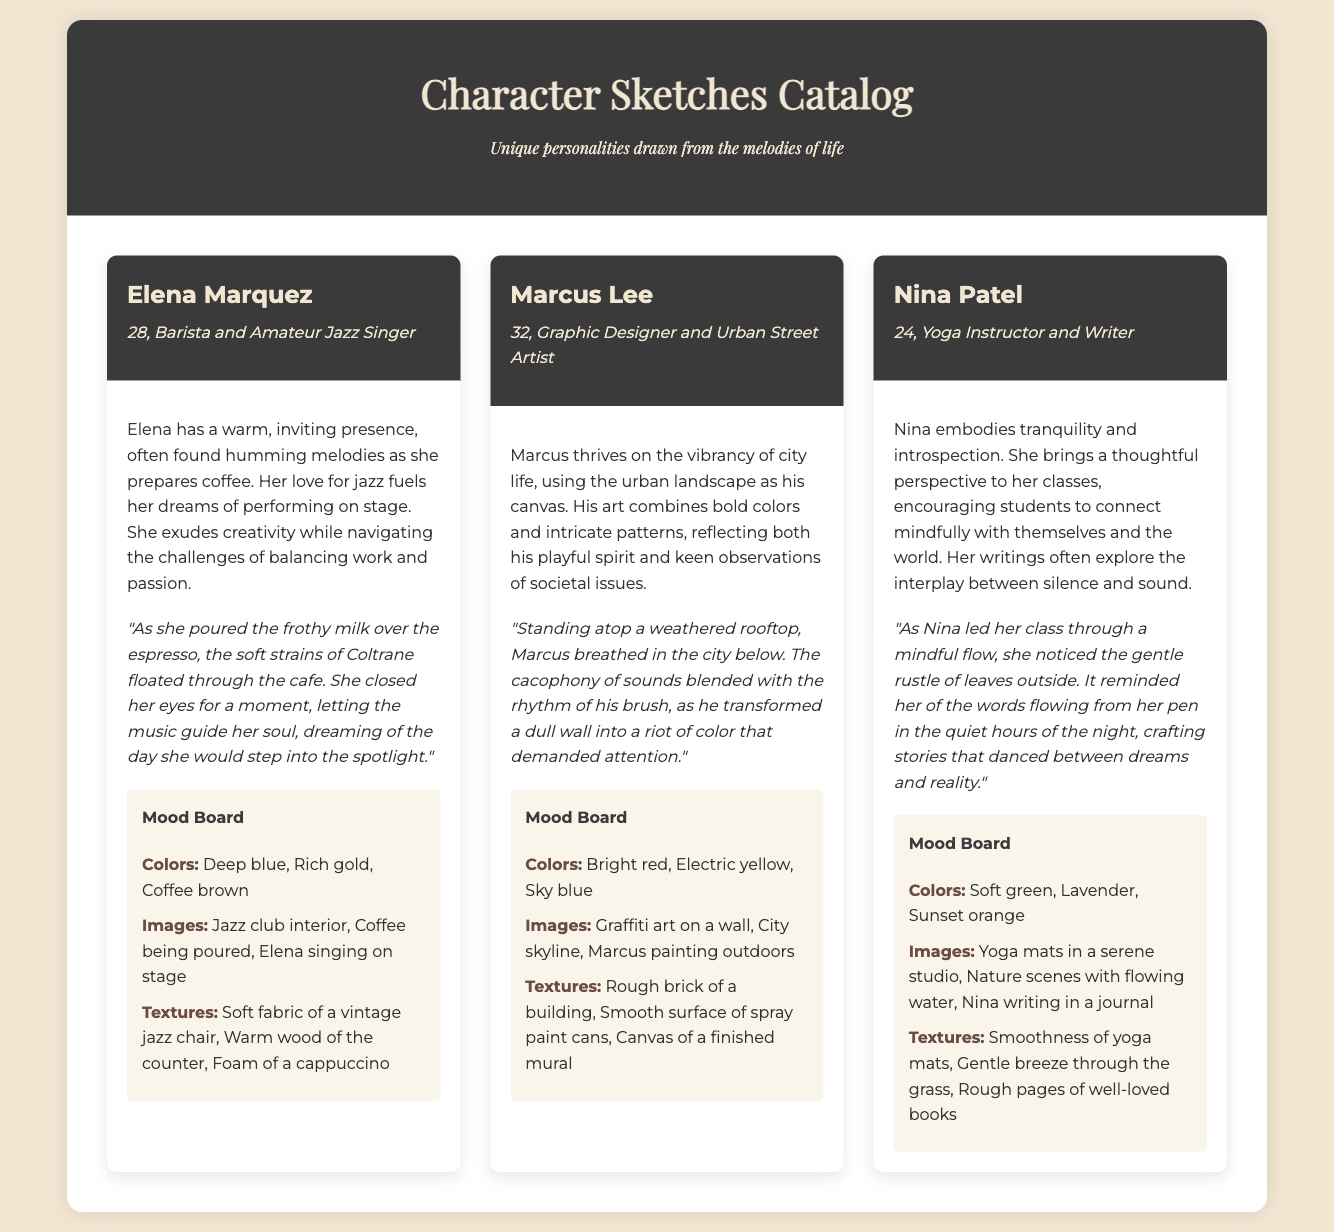What is the name of the first character? The first character in the catalog is introduced as Elena Marquez.
Answer: Elena Marquez What is Marcus Lee's profession? According to the document, Marcus Lee is a Graphic Designer and Urban Street Artist.
Answer: Graphic Designer and Urban Street Artist How old is Nina Patel? The document states that Nina Patel is 24 years old.
Answer: 24 What color is featured in Elena's mood board? One of the colors in Elena's mood board is Deep blue.
Answer: Deep blue What unique quality does Nina bring to her yoga classes? Nina is known for encouraging students to connect mindfully with themselves and the world.
Answer: Mindful connection What is a central theme in Nina's writing? Nina's writings often explore the interplay between silence and sound.
Answer: Silence and sound Which character dreams of performing on stage? The character dreaming of performing on stage is Elena Marquez.
Answer: Elena Marquez What art form does Marcus Lee use to express himself? Marcus Lee uses street art as his medium of expression.
Answer: Street art How does the narrative for Marcus describe his surroundings? The narrative describes Marcus's surroundings as a vibrant city below him.
Answer: Vibrant city 